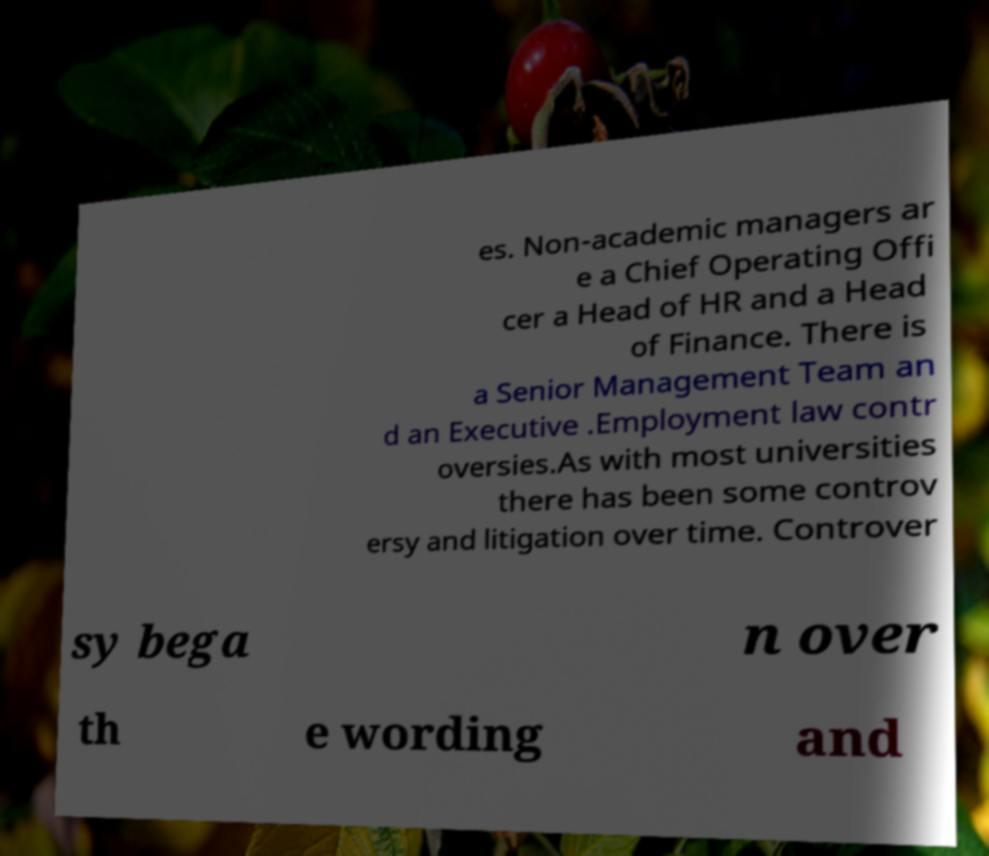Could you extract and type out the text from this image? es. Non-academic managers ar e a Chief Operating Offi cer a Head of HR and a Head of Finance. There is a Senior Management Team an d an Executive .Employment law contr oversies.As with most universities there has been some controv ersy and litigation over time. Controver sy bega n over th e wording and 